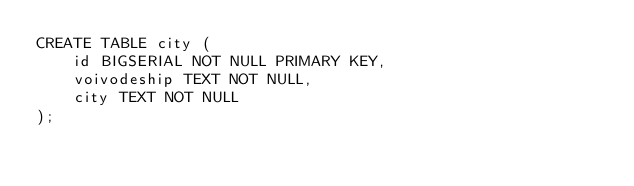Convert code to text. <code><loc_0><loc_0><loc_500><loc_500><_SQL_>CREATE TABLE city (
    id BIGSERIAL NOT NULL PRIMARY KEY,
    voivodeship TEXT NOT NULL,
    city TEXT NOT NULL
);</code> 